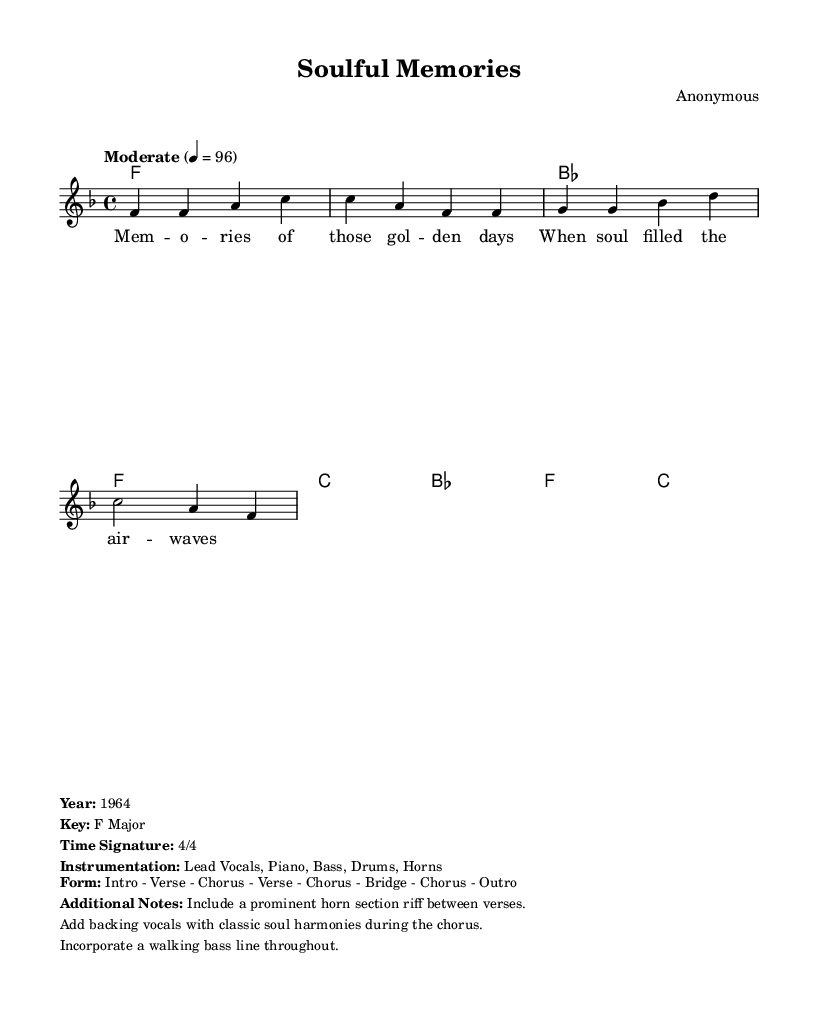What is the key signature of this music? The key signature can be identified by looking at the key indicated at the beginning of the sheet music. In this case, it states "f \major", which indicates that the key signature is F Major, with one flat.
Answer: F Major What is the time signature of this music? The time signature is typically found at the beginning of the sheet music, next to the key signature. Here it shows "4/4", which means there are four beats in a measure and the quarter note gets one beat.
Answer: 4/4 What is the tempo marking for this piece? The tempo marking is located at the beginning of the sheet music and is indicated as "Moderate 4 = 96". This means the piece should be played at a moderate speed with a metronome marking of 96 beats per minute.
Answer: Moderate 4 = 96 How many measures are there in the melody section? To find the number of measures, count the distinct segments divided by vertical lines in the melody part, which shows there are 4 measures as the melody is grouped accordingly.
Answer: 4 What form does this music piece take? The form is provided in the markup section at the bottom of the sheet music. It describes the structure as "Intro - Verse - Chorus - Verse - Chorus - Bridge - Chorus - Outro", indicating how the piece progresses.
Answer: Intro - Verse - Chorus - Verse - Chorus - Bridge - Chorus - Outro What is a notable feature included in the additional notes? The additional notes section mentions specific features of the arrangement. One mentioned is a "prominent horn section riff between verses," highlighting an important aspect of the song's arrangement.
Answer: Prominent horn section riff 